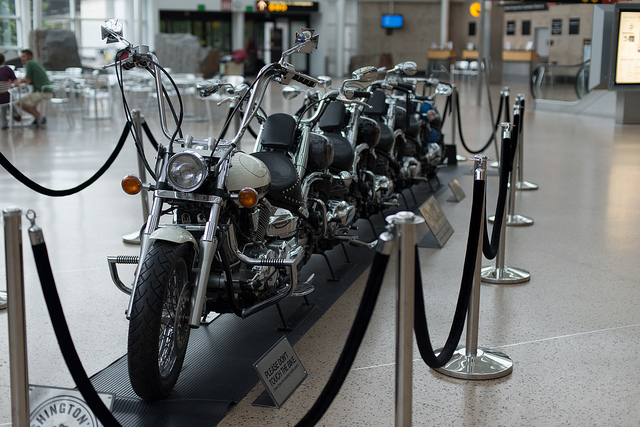Identify the text displayed in this image. HINGTON 